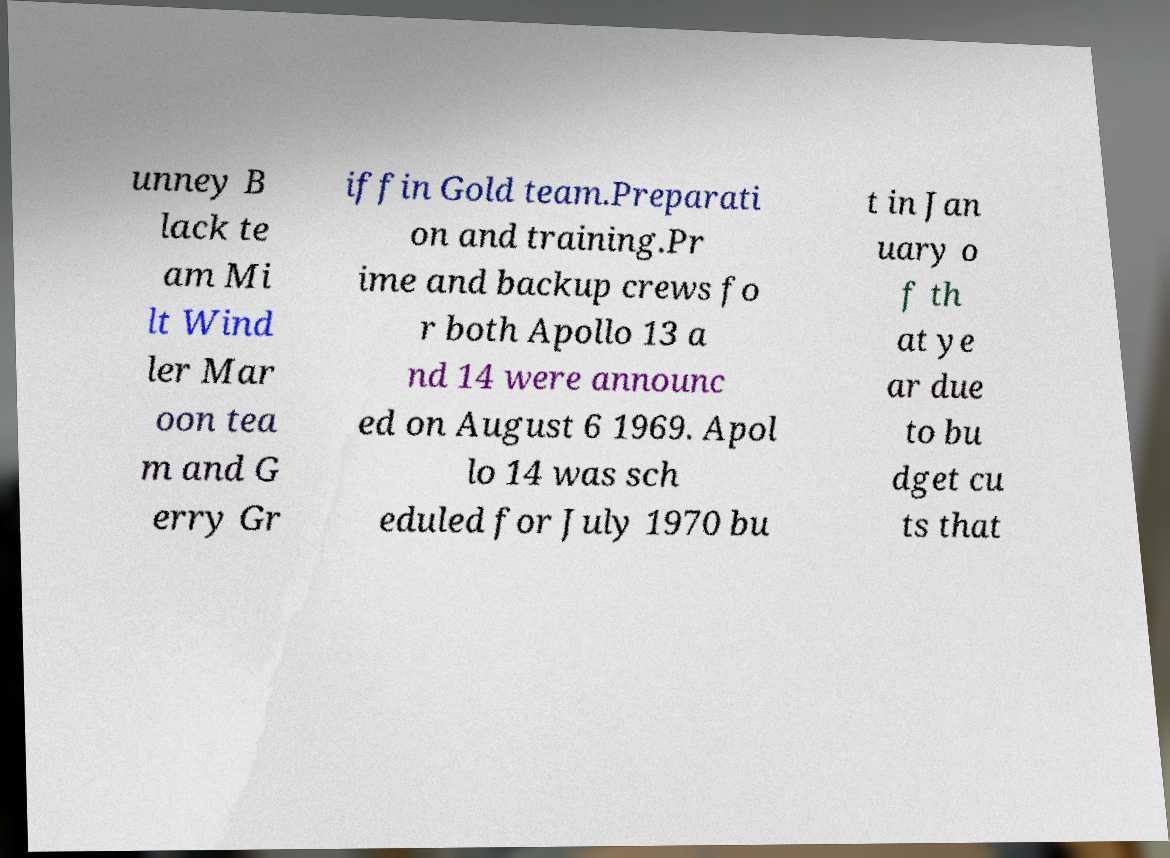Can you read and provide the text displayed in the image?This photo seems to have some interesting text. Can you extract and type it out for me? unney B lack te am Mi lt Wind ler Mar oon tea m and G erry Gr iffin Gold team.Preparati on and training.Pr ime and backup crews fo r both Apollo 13 a nd 14 were announc ed on August 6 1969. Apol lo 14 was sch eduled for July 1970 bu t in Jan uary o f th at ye ar due to bu dget cu ts that 